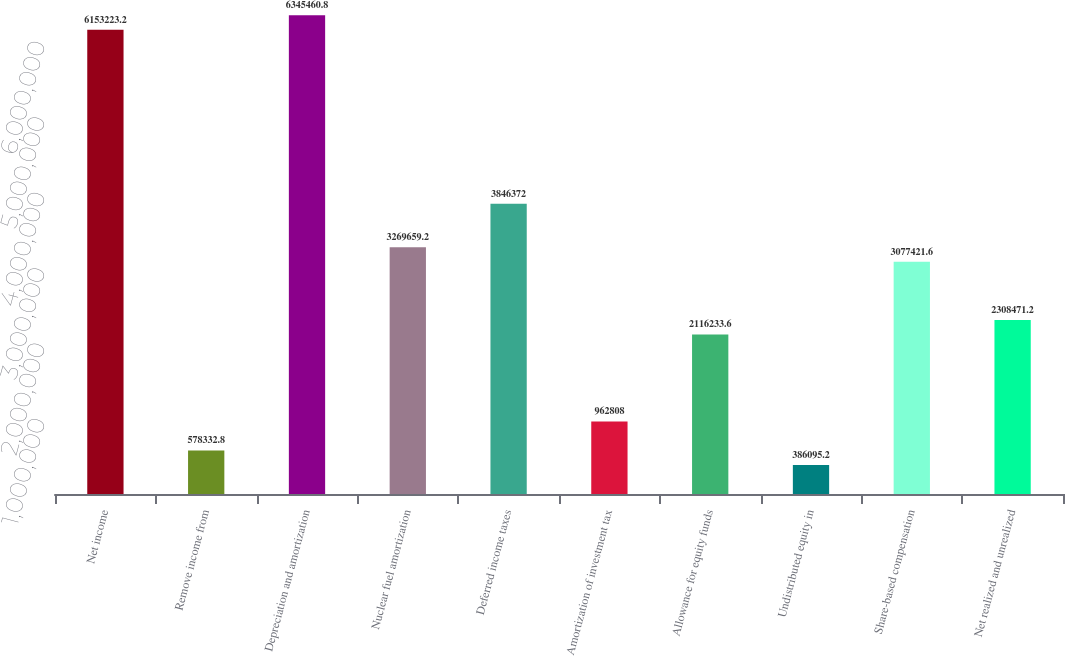Convert chart to OTSL. <chart><loc_0><loc_0><loc_500><loc_500><bar_chart><fcel>Net income<fcel>Remove income from<fcel>Depreciation and amortization<fcel>Nuclear fuel amortization<fcel>Deferred income taxes<fcel>Amortization of investment tax<fcel>Allowance for equity funds<fcel>Undistributed equity in<fcel>Share-based compensation<fcel>Net realized and unrealized<nl><fcel>6.15322e+06<fcel>578333<fcel>6.34546e+06<fcel>3.26966e+06<fcel>3.84637e+06<fcel>962808<fcel>2.11623e+06<fcel>386095<fcel>3.07742e+06<fcel>2.30847e+06<nl></chart> 